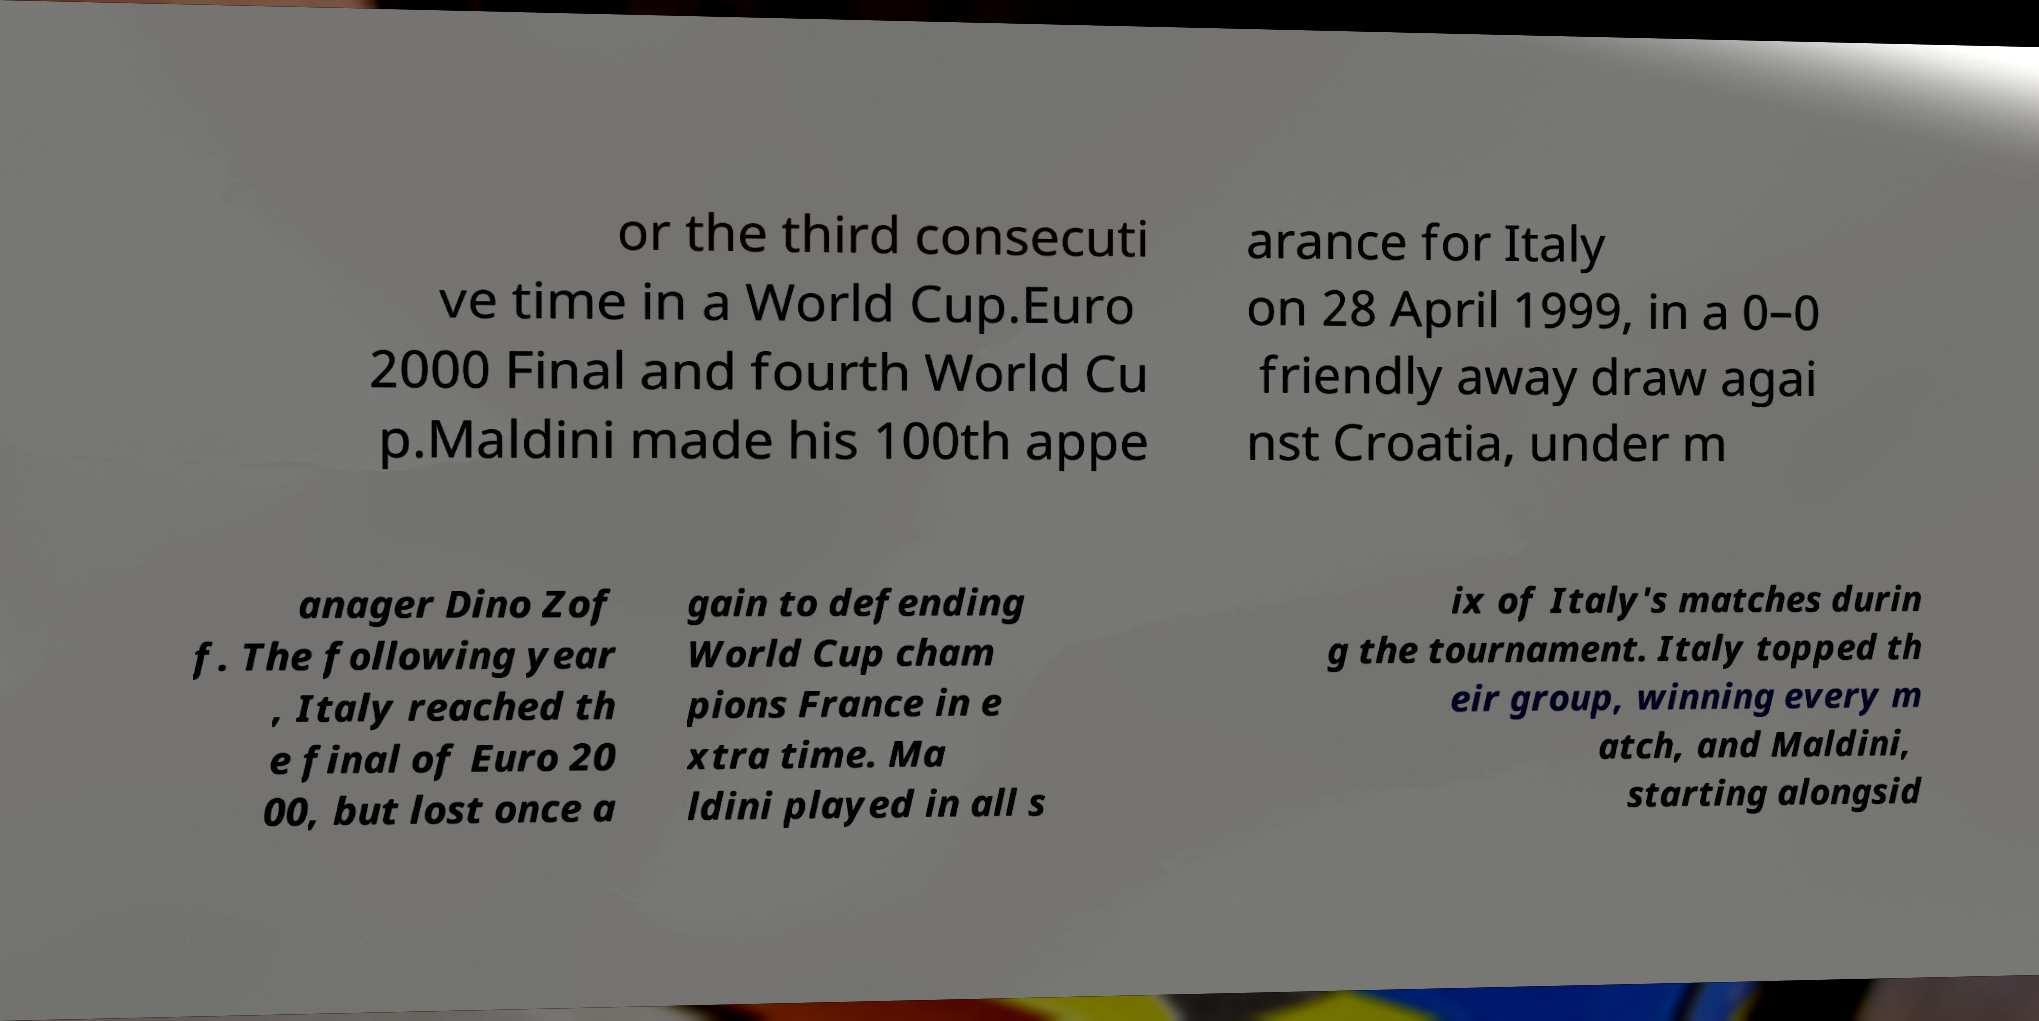Can you read and provide the text displayed in the image?This photo seems to have some interesting text. Can you extract and type it out for me? or the third consecuti ve time in a World Cup.Euro 2000 Final and fourth World Cu p.Maldini made his 100th appe arance for Italy on 28 April 1999, in a 0–0 friendly away draw agai nst Croatia, under m anager Dino Zof f. The following year , Italy reached th e final of Euro 20 00, but lost once a gain to defending World Cup cham pions France in e xtra time. Ma ldini played in all s ix of Italy's matches durin g the tournament. Italy topped th eir group, winning every m atch, and Maldini, starting alongsid 